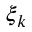Convert formula to latex. <formula><loc_0><loc_0><loc_500><loc_500>\xi _ { k }</formula> 